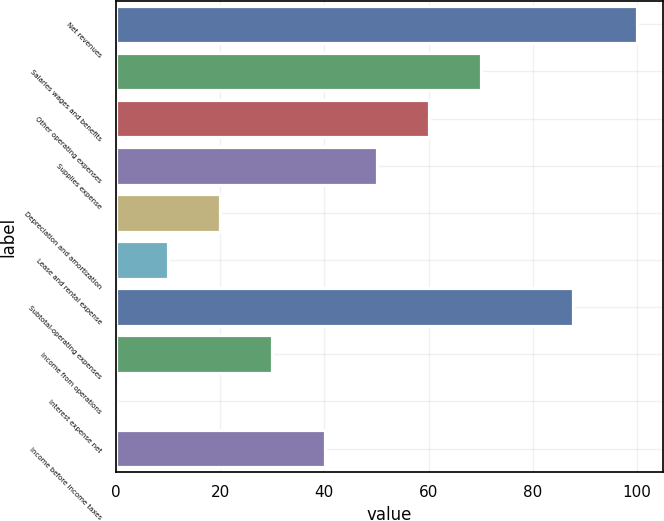<chart> <loc_0><loc_0><loc_500><loc_500><bar_chart><fcel>Net revenues<fcel>Salaries wages and benefits<fcel>Other operating expenses<fcel>Supplies expense<fcel>Depreciation and amortization<fcel>Lease and rental expense<fcel>Subtotal-operating expenses<fcel>Income from operations<fcel>Interest expense net<fcel>Income before income taxes<nl><fcel>100<fcel>70.03<fcel>60.04<fcel>50.05<fcel>20.08<fcel>10.09<fcel>87.7<fcel>30.07<fcel>0.1<fcel>40.06<nl></chart> 